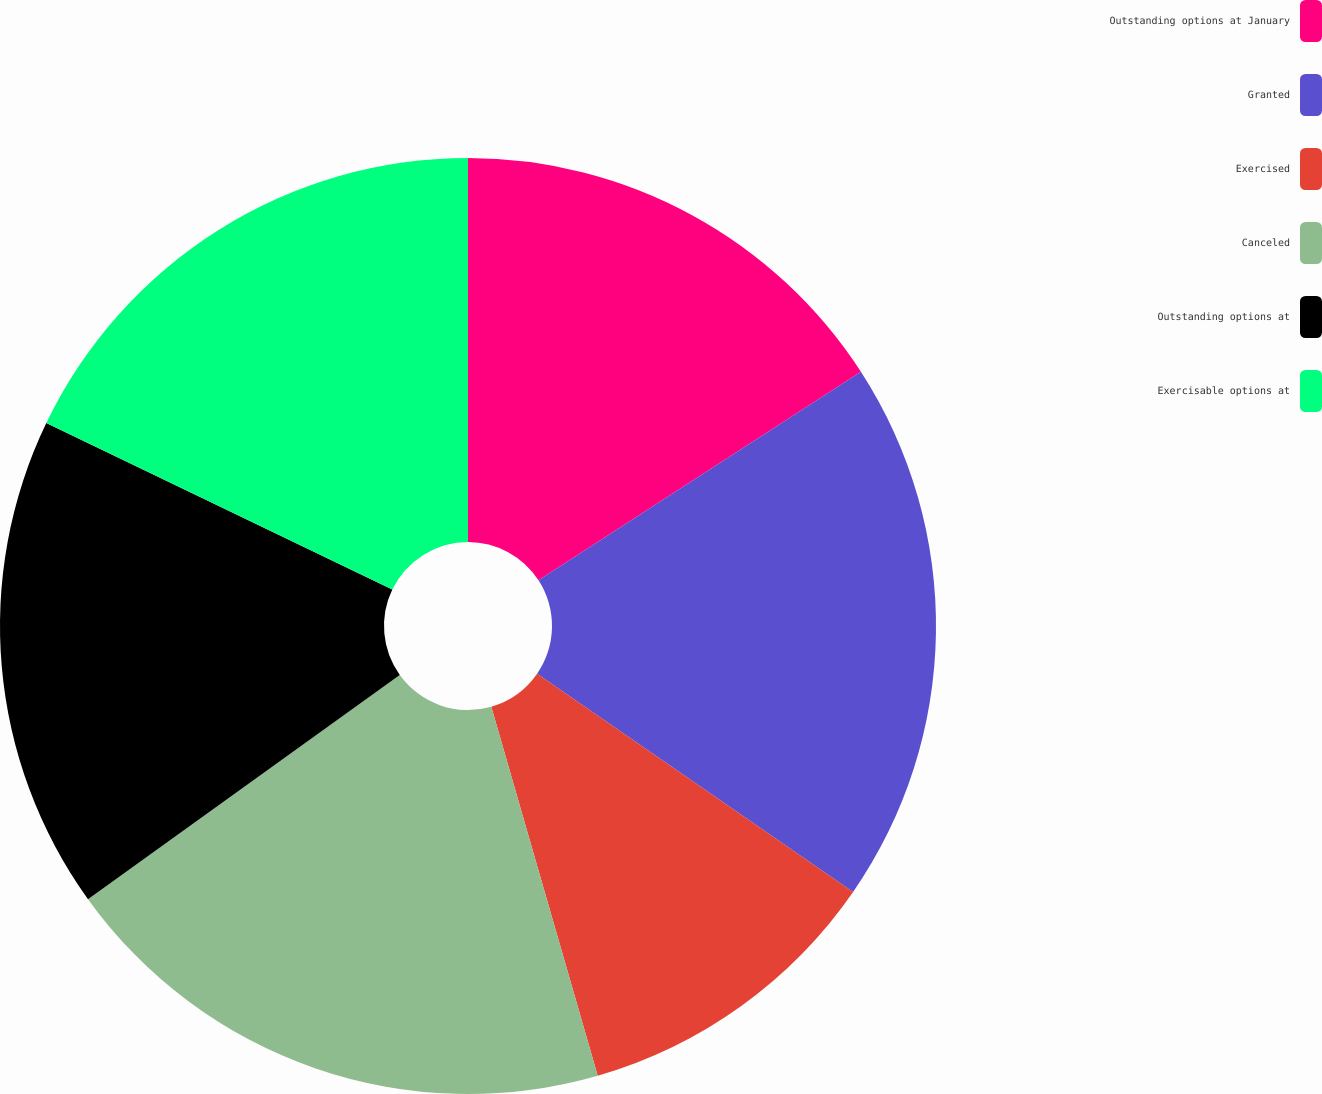Convert chart. <chart><loc_0><loc_0><loc_500><loc_500><pie_chart><fcel>Outstanding options at January<fcel>Granted<fcel>Exercised<fcel>Canceled<fcel>Outstanding options at<fcel>Exercisable options at<nl><fcel>15.86%<fcel>18.76%<fcel>10.91%<fcel>19.55%<fcel>17.06%<fcel>17.86%<nl></chart> 